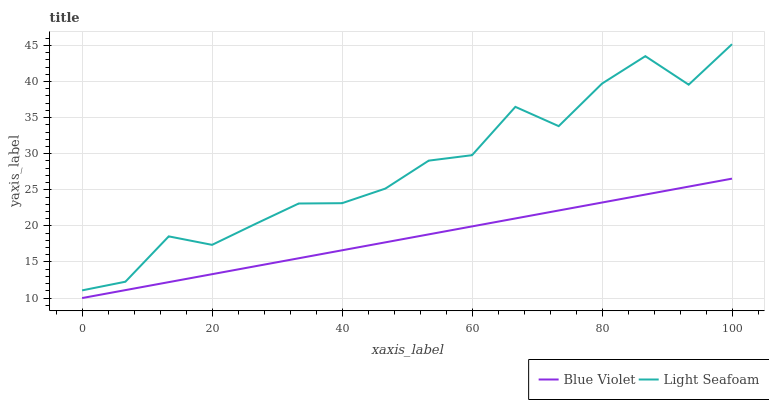Does Blue Violet have the maximum area under the curve?
Answer yes or no. No. Is Blue Violet the roughest?
Answer yes or no. No. Does Blue Violet have the highest value?
Answer yes or no. No. Is Blue Violet less than Light Seafoam?
Answer yes or no. Yes. Is Light Seafoam greater than Blue Violet?
Answer yes or no. Yes. Does Blue Violet intersect Light Seafoam?
Answer yes or no. No. 